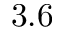<formula> <loc_0><loc_0><loc_500><loc_500>3 . 6</formula> 